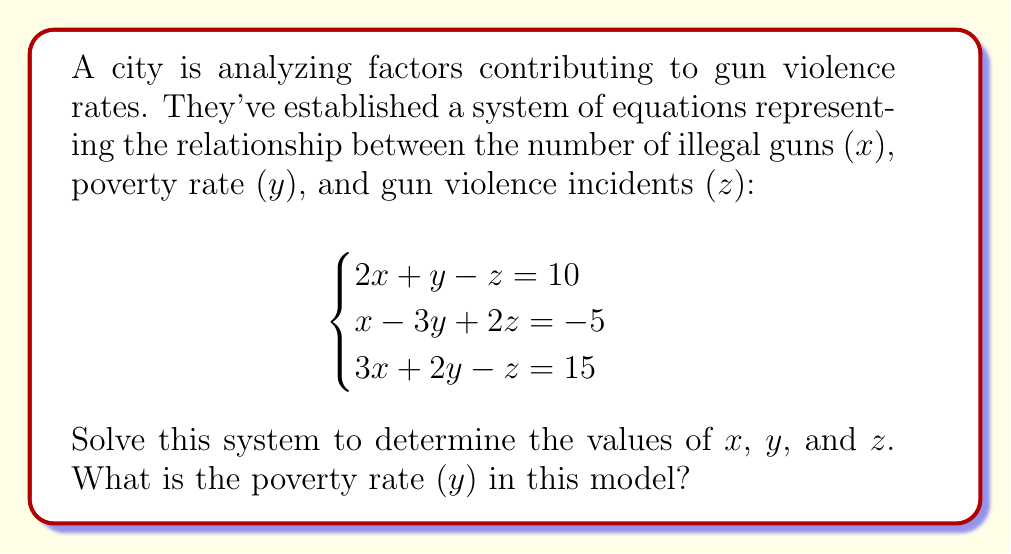Can you solve this math problem? Let's solve this system of equations using the elimination method:

1) First, let's eliminate $z$ by adding equations (1) and (2):
   $$(2x + y - z = 10) + (x - 3y + 2z = -5)$$
   $$3x - 2y + z = 5 \quad \text{(4)}$$

2) Now, add equations (3) and (4):
   $$(3x + 2y - z = 15) + (3x - 2y + z = 5)$$
   $$6x = 20$$
   $$x = \frac{20}{6} = \frac{10}{3}$$

3) Substitute $x = \frac{10}{3}$ into equation (3):
   $$3(\frac{10}{3}) + 2y - z = 15$$
   $$10 + 2y - z = 15$$
   $$2y - z = 5 \quad \text{(5)}$$

4) Subtract equation (5) from equation (1):
   $$(2x + y - z = 10) - (2y - z = 5)$$
   $$2x - y = 5$$
   $$2(\frac{10}{3}) - y = 5$$
   $$\frac{20}{3} - y = 5$$
   $$-y = 5 - \frac{20}{3} = \frac{15-20}{3} = -\frac{5}{3}$$
   $$y = \frac{5}{3}$$

5) Finally, substitute $x = \frac{10}{3}$ and $y = \frac{5}{3}$ into equation (1):
   $$2(\frac{10}{3}) + \frac{5}{3} - z = 10$$
   $$\frac{20}{3} + \frac{5}{3} - z = 10$$
   $$\frac{25}{3} - z = 10$$
   $$-z = 10 - \frac{25}{3} = \frac{30-25}{3} = \frac{5}{3}$$
   $$z = -\frac{5}{3}$$

Thus, we have solved for $x$, $y$, and $z$. The poverty rate is represented by $y$.
Answer: $\frac{5}{3}$ 